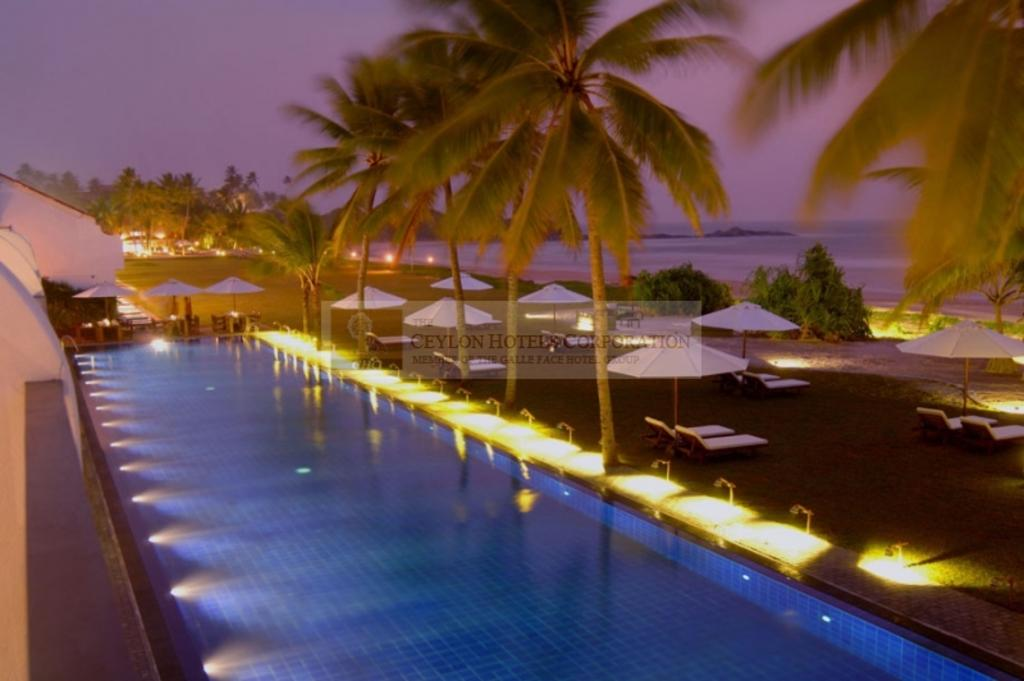What type of water pool is in the image? There is a manual water pool in the image. Where is the water pool located? The water pool is in a garden. What can be seen around the water pool? There are lights around the water pool. What other features are present in the garden? There is a recreation area and trees in the garden. Are there any lights visible in the garden besides those around the water pool? Yes, there are lights visible in the garden. What else can be seen in the image? There is a sea visible in the image, and the sky is visible at the top of the image. What type of sheet is used to cover the sea in the image? There is no sheet present in the image to cover the sea. What rule is being enforced in the garden regarding the smashing of objects? There is no mention of any rules or smashing of objects in the image. 